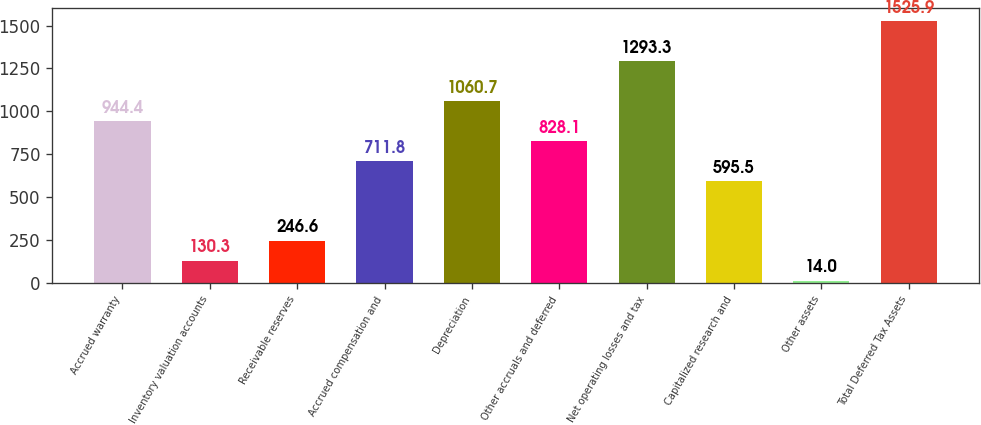<chart> <loc_0><loc_0><loc_500><loc_500><bar_chart><fcel>Accrued warranty<fcel>Inventory valuation accounts<fcel>Receivable reserves<fcel>Accrued compensation and<fcel>Depreciation<fcel>Other accruals and deferred<fcel>Net operating losses and tax<fcel>Capitalized research and<fcel>Other assets<fcel>Total Deferred Tax Assets<nl><fcel>944.4<fcel>130.3<fcel>246.6<fcel>711.8<fcel>1060.7<fcel>828.1<fcel>1293.3<fcel>595.5<fcel>14<fcel>1525.9<nl></chart> 